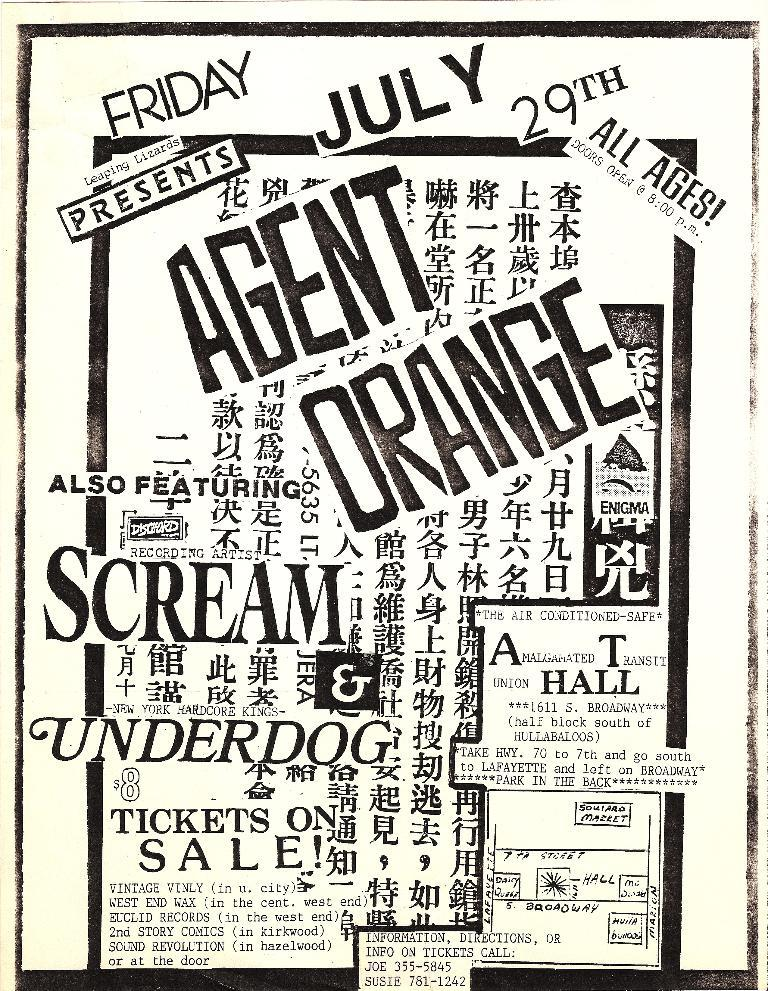<image>
Create a compact narrative representing the image presented. A flyer for an event has many different languages on it. 